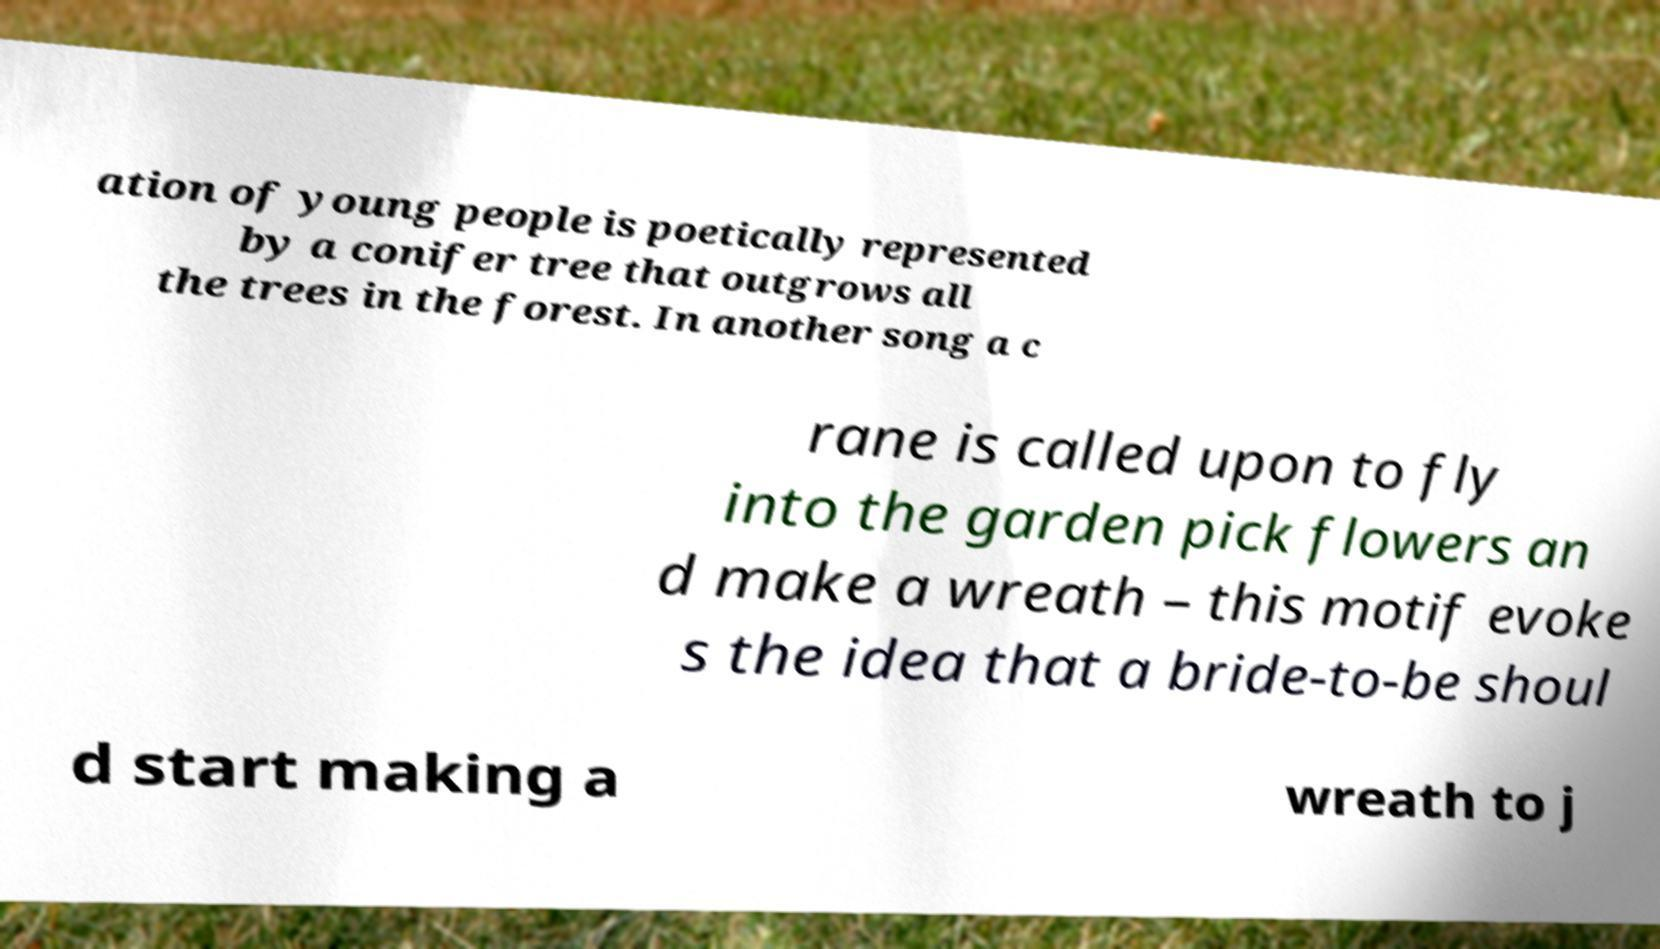Please read and relay the text visible in this image. What does it say? ation of young people is poetically represented by a conifer tree that outgrows all the trees in the forest. In another song a c rane is called upon to fly into the garden pick flowers an d make a wreath – this motif evoke s the idea that a bride-to-be shoul d start making a wreath to j 